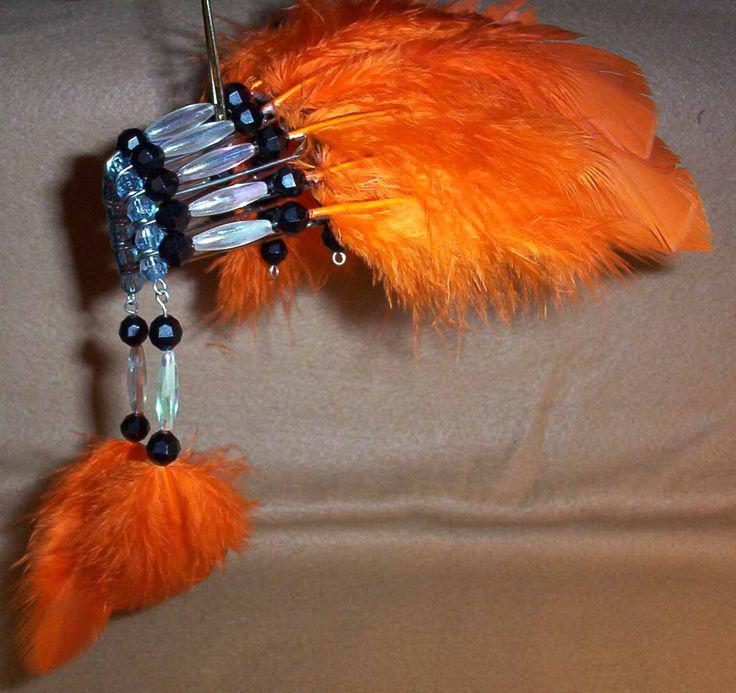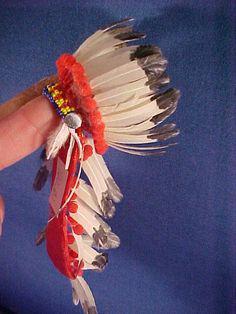The first image is the image on the left, the second image is the image on the right. For the images displayed, is the sentence "Exactly one of the images contains feathers." factually correct? Answer yes or no. No. The first image is the image on the left, the second image is the image on the right. Analyze the images presented: Is the assertion "Left and right images show a decorative item resembling an indian headdress, and at least one of the items is made with blue beads strung on safety pins." valid? Answer yes or no. Yes. 